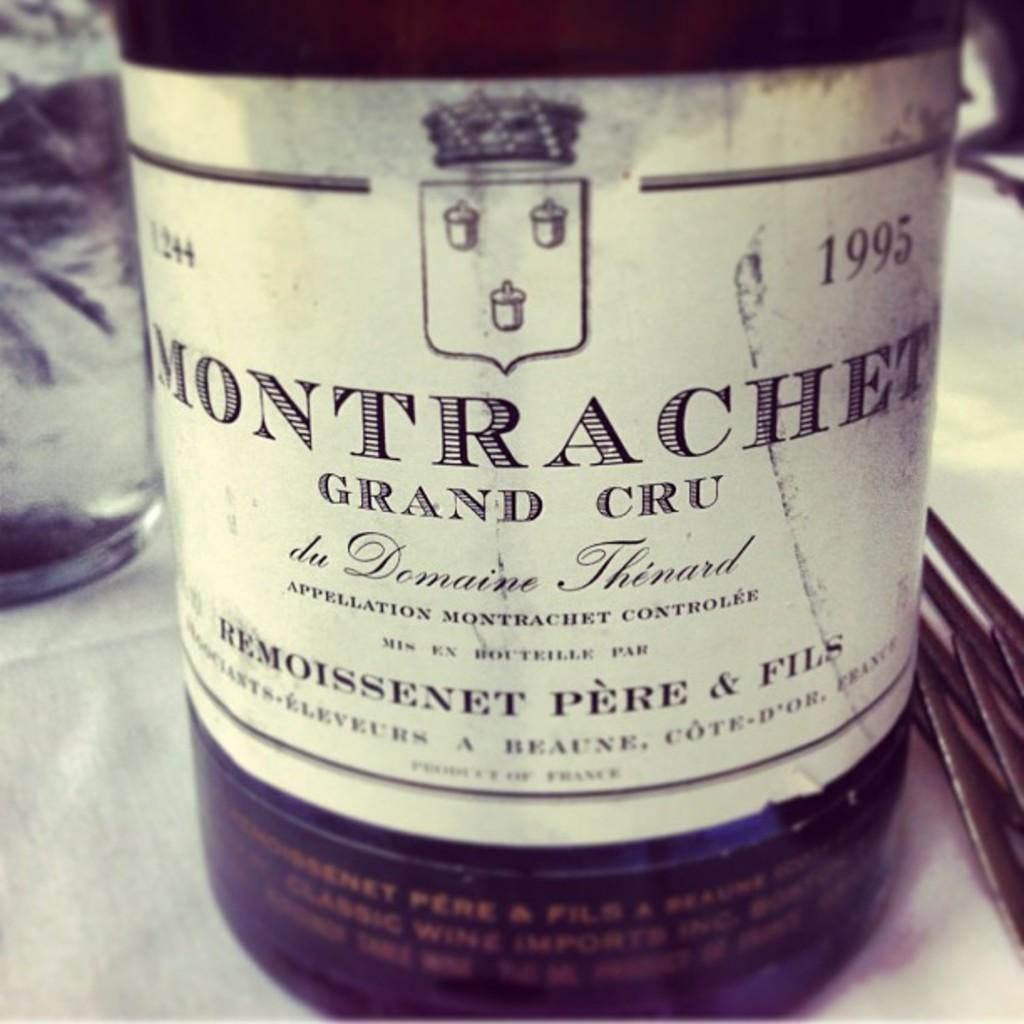<image>
Provide a brief description of the given image. A bottle of 1995 Montrachet is shown up close. 